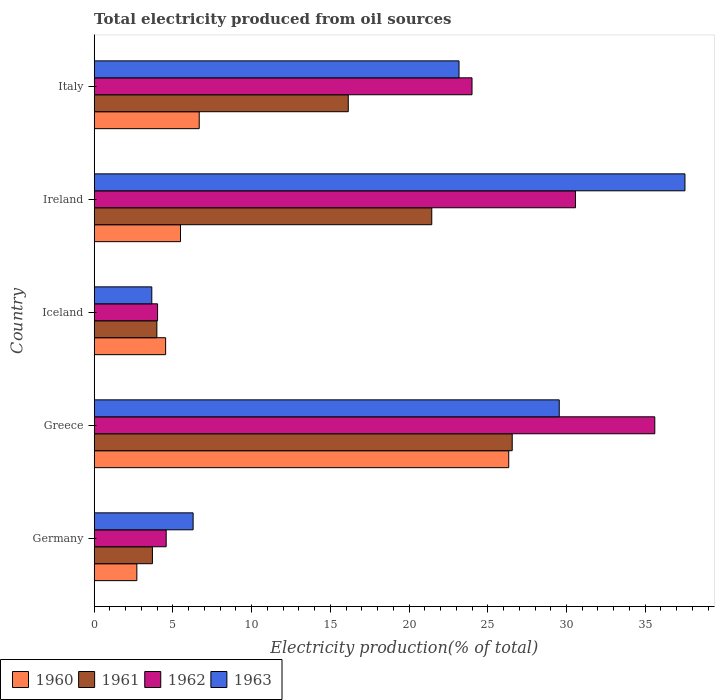How many bars are there on the 3rd tick from the bottom?
Ensure brevity in your answer.  4. What is the total electricity produced in 1962 in Greece?
Your response must be concise. 35.61. Across all countries, what is the maximum total electricity produced in 1963?
Your answer should be very brief. 37.53. Across all countries, what is the minimum total electricity produced in 1960?
Offer a terse response. 2.71. In which country was the total electricity produced in 1961 minimum?
Offer a very short reply. Germany. What is the total total electricity produced in 1962 in the graph?
Ensure brevity in your answer.  98.78. What is the difference between the total electricity produced in 1960 in Greece and that in Ireland?
Offer a very short reply. 20.85. What is the difference between the total electricity produced in 1960 in Iceland and the total electricity produced in 1961 in Germany?
Your response must be concise. 0.84. What is the average total electricity produced in 1963 per country?
Provide a short and direct response. 20.04. What is the difference between the total electricity produced in 1961 and total electricity produced in 1960 in Germany?
Provide a short and direct response. 0.99. In how many countries, is the total electricity produced in 1962 greater than 37 %?
Make the answer very short. 0. What is the ratio of the total electricity produced in 1960 in Greece to that in Ireland?
Offer a very short reply. 4.8. What is the difference between the highest and the second highest total electricity produced in 1963?
Give a very brief answer. 7.99. What is the difference between the highest and the lowest total electricity produced in 1962?
Ensure brevity in your answer.  31.58. Is it the case that in every country, the sum of the total electricity produced in 1961 and total electricity produced in 1963 is greater than the sum of total electricity produced in 1962 and total electricity produced in 1960?
Provide a succinct answer. No. How many bars are there?
Your answer should be very brief. 20. What is the difference between two consecutive major ticks on the X-axis?
Provide a succinct answer. 5. Does the graph contain any zero values?
Ensure brevity in your answer.  No. Does the graph contain grids?
Ensure brevity in your answer.  No. How are the legend labels stacked?
Offer a very short reply. Horizontal. What is the title of the graph?
Provide a succinct answer. Total electricity produced from oil sources. Does "1998" appear as one of the legend labels in the graph?
Offer a terse response. No. What is the label or title of the X-axis?
Ensure brevity in your answer.  Electricity production(% of total). What is the Electricity production(% of total) in 1960 in Germany?
Give a very brief answer. 2.71. What is the Electricity production(% of total) in 1961 in Germany?
Ensure brevity in your answer.  3.7. What is the Electricity production(% of total) of 1962 in Germany?
Make the answer very short. 4.57. What is the Electricity production(% of total) in 1963 in Germany?
Offer a very short reply. 6.28. What is the Electricity production(% of total) of 1960 in Greece?
Your response must be concise. 26.33. What is the Electricity production(% of total) in 1961 in Greece?
Provide a succinct answer. 26.55. What is the Electricity production(% of total) of 1962 in Greece?
Ensure brevity in your answer.  35.61. What is the Electricity production(% of total) of 1963 in Greece?
Offer a terse response. 29.54. What is the Electricity production(% of total) in 1960 in Iceland?
Offer a terse response. 4.54. What is the Electricity production(% of total) in 1961 in Iceland?
Offer a very short reply. 3.98. What is the Electricity production(% of total) of 1962 in Iceland?
Make the answer very short. 4.03. What is the Electricity production(% of total) of 1963 in Iceland?
Provide a short and direct response. 3.66. What is the Electricity production(% of total) in 1960 in Ireland?
Your answer should be very brief. 5.48. What is the Electricity production(% of total) in 1961 in Ireland?
Offer a terse response. 21.44. What is the Electricity production(% of total) of 1962 in Ireland?
Offer a very short reply. 30.57. What is the Electricity production(% of total) in 1963 in Ireland?
Give a very brief answer. 37.53. What is the Electricity production(% of total) of 1960 in Italy?
Ensure brevity in your answer.  6.67. What is the Electricity production(% of total) of 1961 in Italy?
Your response must be concise. 16.14. What is the Electricity production(% of total) in 1962 in Italy?
Provide a short and direct response. 24. What is the Electricity production(% of total) in 1963 in Italy?
Your answer should be compact. 23.17. Across all countries, what is the maximum Electricity production(% of total) in 1960?
Ensure brevity in your answer.  26.33. Across all countries, what is the maximum Electricity production(% of total) of 1961?
Keep it short and to the point. 26.55. Across all countries, what is the maximum Electricity production(% of total) in 1962?
Offer a terse response. 35.61. Across all countries, what is the maximum Electricity production(% of total) of 1963?
Your response must be concise. 37.53. Across all countries, what is the minimum Electricity production(% of total) in 1960?
Provide a short and direct response. 2.71. Across all countries, what is the minimum Electricity production(% of total) in 1961?
Your response must be concise. 3.7. Across all countries, what is the minimum Electricity production(% of total) of 1962?
Ensure brevity in your answer.  4.03. Across all countries, what is the minimum Electricity production(% of total) of 1963?
Make the answer very short. 3.66. What is the total Electricity production(% of total) of 1960 in the graph?
Ensure brevity in your answer.  45.73. What is the total Electricity production(% of total) in 1961 in the graph?
Give a very brief answer. 71.81. What is the total Electricity production(% of total) in 1962 in the graph?
Your response must be concise. 98.78. What is the total Electricity production(% of total) of 1963 in the graph?
Your answer should be compact. 100.18. What is the difference between the Electricity production(% of total) in 1960 in Germany and that in Greece?
Your response must be concise. -23.62. What is the difference between the Electricity production(% of total) of 1961 in Germany and that in Greece?
Your response must be concise. -22.86. What is the difference between the Electricity production(% of total) of 1962 in Germany and that in Greece?
Provide a short and direct response. -31.04. What is the difference between the Electricity production(% of total) of 1963 in Germany and that in Greece?
Keep it short and to the point. -23.26. What is the difference between the Electricity production(% of total) in 1960 in Germany and that in Iceland?
Ensure brevity in your answer.  -1.83. What is the difference between the Electricity production(% of total) of 1961 in Germany and that in Iceland?
Your answer should be very brief. -0.28. What is the difference between the Electricity production(% of total) of 1962 in Germany and that in Iceland?
Your response must be concise. 0.55. What is the difference between the Electricity production(% of total) of 1963 in Germany and that in Iceland?
Provide a short and direct response. 2.63. What is the difference between the Electricity production(% of total) in 1960 in Germany and that in Ireland?
Offer a very short reply. -2.77. What is the difference between the Electricity production(% of total) of 1961 in Germany and that in Ireland?
Your answer should be very brief. -17.75. What is the difference between the Electricity production(% of total) of 1962 in Germany and that in Ireland?
Make the answer very short. -26. What is the difference between the Electricity production(% of total) of 1963 in Germany and that in Ireland?
Provide a succinct answer. -31.24. What is the difference between the Electricity production(% of total) in 1960 in Germany and that in Italy?
Your answer should be very brief. -3.96. What is the difference between the Electricity production(% of total) in 1961 in Germany and that in Italy?
Ensure brevity in your answer.  -12.44. What is the difference between the Electricity production(% of total) in 1962 in Germany and that in Italy?
Keep it short and to the point. -19.43. What is the difference between the Electricity production(% of total) in 1963 in Germany and that in Italy?
Provide a succinct answer. -16.89. What is the difference between the Electricity production(% of total) of 1960 in Greece and that in Iceland?
Provide a short and direct response. 21.79. What is the difference between the Electricity production(% of total) of 1961 in Greece and that in Iceland?
Offer a very short reply. 22.57. What is the difference between the Electricity production(% of total) in 1962 in Greece and that in Iceland?
Provide a succinct answer. 31.58. What is the difference between the Electricity production(% of total) of 1963 in Greece and that in Iceland?
Ensure brevity in your answer.  25.88. What is the difference between the Electricity production(% of total) of 1960 in Greece and that in Ireland?
Your response must be concise. 20.85. What is the difference between the Electricity production(% of total) of 1961 in Greece and that in Ireland?
Offer a very short reply. 5.11. What is the difference between the Electricity production(% of total) of 1962 in Greece and that in Ireland?
Keep it short and to the point. 5.04. What is the difference between the Electricity production(% of total) of 1963 in Greece and that in Ireland?
Offer a terse response. -7.99. What is the difference between the Electricity production(% of total) of 1960 in Greece and that in Italy?
Your answer should be compact. 19.66. What is the difference between the Electricity production(% of total) of 1961 in Greece and that in Italy?
Provide a short and direct response. 10.42. What is the difference between the Electricity production(% of total) in 1962 in Greece and that in Italy?
Keep it short and to the point. 11.61. What is the difference between the Electricity production(% of total) of 1963 in Greece and that in Italy?
Offer a terse response. 6.37. What is the difference between the Electricity production(% of total) of 1960 in Iceland and that in Ireland?
Provide a succinct answer. -0.94. What is the difference between the Electricity production(% of total) of 1961 in Iceland and that in Ireland?
Ensure brevity in your answer.  -17.46. What is the difference between the Electricity production(% of total) of 1962 in Iceland and that in Ireland?
Keep it short and to the point. -26.55. What is the difference between the Electricity production(% of total) in 1963 in Iceland and that in Ireland?
Your response must be concise. -33.87. What is the difference between the Electricity production(% of total) in 1960 in Iceland and that in Italy?
Give a very brief answer. -2.13. What is the difference between the Electricity production(% of total) of 1961 in Iceland and that in Italy?
Your response must be concise. -12.16. What is the difference between the Electricity production(% of total) of 1962 in Iceland and that in Italy?
Make the answer very short. -19.97. What is the difference between the Electricity production(% of total) in 1963 in Iceland and that in Italy?
Give a very brief answer. -19.52. What is the difference between the Electricity production(% of total) in 1960 in Ireland and that in Italy?
Provide a short and direct response. -1.19. What is the difference between the Electricity production(% of total) of 1961 in Ireland and that in Italy?
Your response must be concise. 5.3. What is the difference between the Electricity production(% of total) in 1962 in Ireland and that in Italy?
Give a very brief answer. 6.57. What is the difference between the Electricity production(% of total) in 1963 in Ireland and that in Italy?
Provide a succinct answer. 14.35. What is the difference between the Electricity production(% of total) in 1960 in Germany and the Electricity production(% of total) in 1961 in Greece?
Offer a terse response. -23.85. What is the difference between the Electricity production(% of total) in 1960 in Germany and the Electricity production(% of total) in 1962 in Greece?
Ensure brevity in your answer.  -32.9. What is the difference between the Electricity production(% of total) of 1960 in Germany and the Electricity production(% of total) of 1963 in Greece?
Offer a terse response. -26.83. What is the difference between the Electricity production(% of total) in 1961 in Germany and the Electricity production(% of total) in 1962 in Greece?
Your answer should be compact. -31.91. What is the difference between the Electricity production(% of total) in 1961 in Germany and the Electricity production(% of total) in 1963 in Greece?
Keep it short and to the point. -25.84. What is the difference between the Electricity production(% of total) in 1962 in Germany and the Electricity production(% of total) in 1963 in Greece?
Your answer should be compact. -24.97. What is the difference between the Electricity production(% of total) in 1960 in Germany and the Electricity production(% of total) in 1961 in Iceland?
Offer a very short reply. -1.27. What is the difference between the Electricity production(% of total) in 1960 in Germany and the Electricity production(% of total) in 1962 in Iceland?
Provide a succinct answer. -1.32. What is the difference between the Electricity production(% of total) of 1960 in Germany and the Electricity production(% of total) of 1963 in Iceland?
Give a very brief answer. -0.95. What is the difference between the Electricity production(% of total) of 1961 in Germany and the Electricity production(% of total) of 1962 in Iceland?
Keep it short and to the point. -0.33. What is the difference between the Electricity production(% of total) of 1961 in Germany and the Electricity production(% of total) of 1963 in Iceland?
Offer a terse response. 0.04. What is the difference between the Electricity production(% of total) of 1962 in Germany and the Electricity production(% of total) of 1963 in Iceland?
Keep it short and to the point. 0.91. What is the difference between the Electricity production(% of total) in 1960 in Germany and the Electricity production(% of total) in 1961 in Ireland?
Your response must be concise. -18.73. What is the difference between the Electricity production(% of total) of 1960 in Germany and the Electricity production(% of total) of 1962 in Ireland?
Your answer should be very brief. -27.86. What is the difference between the Electricity production(% of total) in 1960 in Germany and the Electricity production(% of total) in 1963 in Ireland?
Offer a very short reply. -34.82. What is the difference between the Electricity production(% of total) of 1961 in Germany and the Electricity production(% of total) of 1962 in Ireland?
Make the answer very short. -26.87. What is the difference between the Electricity production(% of total) in 1961 in Germany and the Electricity production(% of total) in 1963 in Ireland?
Provide a succinct answer. -33.83. What is the difference between the Electricity production(% of total) of 1962 in Germany and the Electricity production(% of total) of 1963 in Ireland?
Provide a short and direct response. -32.95. What is the difference between the Electricity production(% of total) of 1960 in Germany and the Electricity production(% of total) of 1961 in Italy?
Offer a terse response. -13.43. What is the difference between the Electricity production(% of total) in 1960 in Germany and the Electricity production(% of total) in 1962 in Italy?
Your answer should be very brief. -21.29. What is the difference between the Electricity production(% of total) in 1960 in Germany and the Electricity production(% of total) in 1963 in Italy?
Make the answer very short. -20.47. What is the difference between the Electricity production(% of total) of 1961 in Germany and the Electricity production(% of total) of 1962 in Italy?
Offer a very short reply. -20.3. What is the difference between the Electricity production(% of total) of 1961 in Germany and the Electricity production(% of total) of 1963 in Italy?
Offer a very short reply. -19.48. What is the difference between the Electricity production(% of total) in 1962 in Germany and the Electricity production(% of total) in 1963 in Italy?
Your response must be concise. -18.6. What is the difference between the Electricity production(% of total) of 1960 in Greece and the Electricity production(% of total) of 1961 in Iceland?
Your response must be concise. 22.35. What is the difference between the Electricity production(% of total) in 1960 in Greece and the Electricity production(% of total) in 1962 in Iceland?
Your answer should be very brief. 22.31. What is the difference between the Electricity production(% of total) in 1960 in Greece and the Electricity production(% of total) in 1963 in Iceland?
Give a very brief answer. 22.67. What is the difference between the Electricity production(% of total) in 1961 in Greece and the Electricity production(% of total) in 1962 in Iceland?
Your answer should be compact. 22.53. What is the difference between the Electricity production(% of total) in 1961 in Greece and the Electricity production(% of total) in 1963 in Iceland?
Your answer should be very brief. 22.9. What is the difference between the Electricity production(% of total) of 1962 in Greece and the Electricity production(% of total) of 1963 in Iceland?
Give a very brief answer. 31.95. What is the difference between the Electricity production(% of total) in 1960 in Greece and the Electricity production(% of total) in 1961 in Ireland?
Provide a short and direct response. 4.89. What is the difference between the Electricity production(% of total) in 1960 in Greece and the Electricity production(% of total) in 1962 in Ireland?
Give a very brief answer. -4.24. What is the difference between the Electricity production(% of total) in 1960 in Greece and the Electricity production(% of total) in 1963 in Ireland?
Ensure brevity in your answer.  -11.19. What is the difference between the Electricity production(% of total) in 1961 in Greece and the Electricity production(% of total) in 1962 in Ireland?
Your response must be concise. -4.02. What is the difference between the Electricity production(% of total) of 1961 in Greece and the Electricity production(% of total) of 1963 in Ireland?
Make the answer very short. -10.97. What is the difference between the Electricity production(% of total) of 1962 in Greece and the Electricity production(% of total) of 1963 in Ireland?
Provide a short and direct response. -1.92. What is the difference between the Electricity production(% of total) of 1960 in Greece and the Electricity production(% of total) of 1961 in Italy?
Provide a succinct answer. 10.19. What is the difference between the Electricity production(% of total) of 1960 in Greece and the Electricity production(% of total) of 1962 in Italy?
Ensure brevity in your answer.  2.33. What is the difference between the Electricity production(% of total) of 1960 in Greece and the Electricity production(% of total) of 1963 in Italy?
Your answer should be compact. 3.16. What is the difference between the Electricity production(% of total) in 1961 in Greece and the Electricity production(% of total) in 1962 in Italy?
Offer a very short reply. 2.55. What is the difference between the Electricity production(% of total) of 1961 in Greece and the Electricity production(% of total) of 1963 in Italy?
Give a very brief answer. 3.38. What is the difference between the Electricity production(% of total) of 1962 in Greece and the Electricity production(% of total) of 1963 in Italy?
Ensure brevity in your answer.  12.44. What is the difference between the Electricity production(% of total) in 1960 in Iceland and the Electricity production(% of total) in 1961 in Ireland?
Ensure brevity in your answer.  -16.91. What is the difference between the Electricity production(% of total) in 1960 in Iceland and the Electricity production(% of total) in 1962 in Ireland?
Offer a very short reply. -26.03. What is the difference between the Electricity production(% of total) in 1960 in Iceland and the Electricity production(% of total) in 1963 in Ireland?
Your answer should be very brief. -32.99. What is the difference between the Electricity production(% of total) in 1961 in Iceland and the Electricity production(% of total) in 1962 in Ireland?
Give a very brief answer. -26.59. What is the difference between the Electricity production(% of total) of 1961 in Iceland and the Electricity production(% of total) of 1963 in Ireland?
Offer a terse response. -33.55. What is the difference between the Electricity production(% of total) in 1962 in Iceland and the Electricity production(% of total) in 1963 in Ireland?
Make the answer very short. -33.5. What is the difference between the Electricity production(% of total) of 1960 in Iceland and the Electricity production(% of total) of 1961 in Italy?
Your answer should be very brief. -11.6. What is the difference between the Electricity production(% of total) of 1960 in Iceland and the Electricity production(% of total) of 1962 in Italy?
Provide a short and direct response. -19.46. What is the difference between the Electricity production(% of total) of 1960 in Iceland and the Electricity production(% of total) of 1963 in Italy?
Offer a terse response. -18.64. What is the difference between the Electricity production(% of total) of 1961 in Iceland and the Electricity production(% of total) of 1962 in Italy?
Provide a short and direct response. -20.02. What is the difference between the Electricity production(% of total) of 1961 in Iceland and the Electricity production(% of total) of 1963 in Italy?
Keep it short and to the point. -19.19. What is the difference between the Electricity production(% of total) in 1962 in Iceland and the Electricity production(% of total) in 1963 in Italy?
Make the answer very short. -19.15. What is the difference between the Electricity production(% of total) in 1960 in Ireland and the Electricity production(% of total) in 1961 in Italy?
Ensure brevity in your answer.  -10.66. What is the difference between the Electricity production(% of total) in 1960 in Ireland and the Electricity production(% of total) in 1962 in Italy?
Make the answer very short. -18.52. What is the difference between the Electricity production(% of total) in 1960 in Ireland and the Electricity production(% of total) in 1963 in Italy?
Offer a terse response. -17.69. What is the difference between the Electricity production(% of total) in 1961 in Ireland and the Electricity production(% of total) in 1962 in Italy?
Offer a very short reply. -2.56. What is the difference between the Electricity production(% of total) in 1961 in Ireland and the Electricity production(% of total) in 1963 in Italy?
Provide a short and direct response. -1.73. What is the difference between the Electricity production(% of total) in 1962 in Ireland and the Electricity production(% of total) in 1963 in Italy?
Ensure brevity in your answer.  7.4. What is the average Electricity production(% of total) of 1960 per country?
Keep it short and to the point. 9.15. What is the average Electricity production(% of total) in 1961 per country?
Make the answer very short. 14.36. What is the average Electricity production(% of total) of 1962 per country?
Offer a very short reply. 19.76. What is the average Electricity production(% of total) of 1963 per country?
Provide a short and direct response. 20.04. What is the difference between the Electricity production(% of total) in 1960 and Electricity production(% of total) in 1961 in Germany?
Provide a short and direct response. -0.99. What is the difference between the Electricity production(% of total) of 1960 and Electricity production(% of total) of 1962 in Germany?
Provide a succinct answer. -1.86. What is the difference between the Electricity production(% of total) in 1960 and Electricity production(% of total) in 1963 in Germany?
Offer a very short reply. -3.58. What is the difference between the Electricity production(% of total) of 1961 and Electricity production(% of total) of 1962 in Germany?
Keep it short and to the point. -0.87. What is the difference between the Electricity production(% of total) of 1961 and Electricity production(% of total) of 1963 in Germany?
Your response must be concise. -2.59. What is the difference between the Electricity production(% of total) of 1962 and Electricity production(% of total) of 1963 in Germany?
Your response must be concise. -1.71. What is the difference between the Electricity production(% of total) of 1960 and Electricity production(% of total) of 1961 in Greece?
Your answer should be compact. -0.22. What is the difference between the Electricity production(% of total) of 1960 and Electricity production(% of total) of 1962 in Greece?
Offer a very short reply. -9.28. What is the difference between the Electricity production(% of total) of 1960 and Electricity production(% of total) of 1963 in Greece?
Offer a terse response. -3.21. What is the difference between the Electricity production(% of total) of 1961 and Electricity production(% of total) of 1962 in Greece?
Provide a short and direct response. -9.06. What is the difference between the Electricity production(% of total) in 1961 and Electricity production(% of total) in 1963 in Greece?
Offer a terse response. -2.99. What is the difference between the Electricity production(% of total) in 1962 and Electricity production(% of total) in 1963 in Greece?
Your answer should be compact. 6.07. What is the difference between the Electricity production(% of total) of 1960 and Electricity production(% of total) of 1961 in Iceland?
Give a very brief answer. 0.56. What is the difference between the Electricity production(% of total) of 1960 and Electricity production(% of total) of 1962 in Iceland?
Give a very brief answer. 0.51. What is the difference between the Electricity production(% of total) in 1960 and Electricity production(% of total) in 1963 in Iceland?
Ensure brevity in your answer.  0.88. What is the difference between the Electricity production(% of total) of 1961 and Electricity production(% of total) of 1962 in Iceland?
Provide a succinct answer. -0.05. What is the difference between the Electricity production(% of total) of 1961 and Electricity production(% of total) of 1963 in Iceland?
Your response must be concise. 0.32. What is the difference between the Electricity production(% of total) of 1962 and Electricity production(% of total) of 1963 in Iceland?
Make the answer very short. 0.37. What is the difference between the Electricity production(% of total) of 1960 and Electricity production(% of total) of 1961 in Ireland?
Make the answer very short. -15.96. What is the difference between the Electricity production(% of total) in 1960 and Electricity production(% of total) in 1962 in Ireland?
Provide a short and direct response. -25.09. What is the difference between the Electricity production(% of total) in 1960 and Electricity production(% of total) in 1963 in Ireland?
Your answer should be compact. -32.04. What is the difference between the Electricity production(% of total) of 1961 and Electricity production(% of total) of 1962 in Ireland?
Make the answer very short. -9.13. What is the difference between the Electricity production(% of total) of 1961 and Electricity production(% of total) of 1963 in Ireland?
Provide a succinct answer. -16.08. What is the difference between the Electricity production(% of total) of 1962 and Electricity production(% of total) of 1963 in Ireland?
Your answer should be compact. -6.95. What is the difference between the Electricity production(% of total) of 1960 and Electricity production(% of total) of 1961 in Italy?
Give a very brief answer. -9.47. What is the difference between the Electricity production(% of total) of 1960 and Electricity production(% of total) of 1962 in Italy?
Offer a very short reply. -17.33. What is the difference between the Electricity production(% of total) in 1960 and Electricity production(% of total) in 1963 in Italy?
Provide a succinct answer. -16.5. What is the difference between the Electricity production(% of total) in 1961 and Electricity production(% of total) in 1962 in Italy?
Provide a short and direct response. -7.86. What is the difference between the Electricity production(% of total) in 1961 and Electricity production(% of total) in 1963 in Italy?
Make the answer very short. -7.04. What is the difference between the Electricity production(% of total) in 1962 and Electricity production(% of total) in 1963 in Italy?
Keep it short and to the point. 0.83. What is the ratio of the Electricity production(% of total) of 1960 in Germany to that in Greece?
Your response must be concise. 0.1. What is the ratio of the Electricity production(% of total) of 1961 in Germany to that in Greece?
Provide a succinct answer. 0.14. What is the ratio of the Electricity production(% of total) of 1962 in Germany to that in Greece?
Offer a very short reply. 0.13. What is the ratio of the Electricity production(% of total) in 1963 in Germany to that in Greece?
Offer a terse response. 0.21. What is the ratio of the Electricity production(% of total) in 1960 in Germany to that in Iceland?
Your answer should be very brief. 0.6. What is the ratio of the Electricity production(% of total) of 1961 in Germany to that in Iceland?
Give a very brief answer. 0.93. What is the ratio of the Electricity production(% of total) in 1962 in Germany to that in Iceland?
Ensure brevity in your answer.  1.14. What is the ratio of the Electricity production(% of total) in 1963 in Germany to that in Iceland?
Keep it short and to the point. 1.72. What is the ratio of the Electricity production(% of total) in 1960 in Germany to that in Ireland?
Your response must be concise. 0.49. What is the ratio of the Electricity production(% of total) of 1961 in Germany to that in Ireland?
Give a very brief answer. 0.17. What is the ratio of the Electricity production(% of total) of 1962 in Germany to that in Ireland?
Your answer should be very brief. 0.15. What is the ratio of the Electricity production(% of total) in 1963 in Germany to that in Ireland?
Make the answer very short. 0.17. What is the ratio of the Electricity production(% of total) of 1960 in Germany to that in Italy?
Your answer should be compact. 0.41. What is the ratio of the Electricity production(% of total) in 1961 in Germany to that in Italy?
Your answer should be very brief. 0.23. What is the ratio of the Electricity production(% of total) of 1962 in Germany to that in Italy?
Your response must be concise. 0.19. What is the ratio of the Electricity production(% of total) in 1963 in Germany to that in Italy?
Offer a very short reply. 0.27. What is the ratio of the Electricity production(% of total) in 1960 in Greece to that in Iceland?
Make the answer very short. 5.8. What is the ratio of the Electricity production(% of total) of 1961 in Greece to that in Iceland?
Offer a terse response. 6.67. What is the ratio of the Electricity production(% of total) of 1962 in Greece to that in Iceland?
Your response must be concise. 8.85. What is the ratio of the Electricity production(% of total) in 1963 in Greece to that in Iceland?
Provide a short and direct response. 8.07. What is the ratio of the Electricity production(% of total) of 1960 in Greece to that in Ireland?
Your response must be concise. 4.8. What is the ratio of the Electricity production(% of total) of 1961 in Greece to that in Ireland?
Keep it short and to the point. 1.24. What is the ratio of the Electricity production(% of total) of 1962 in Greece to that in Ireland?
Make the answer very short. 1.16. What is the ratio of the Electricity production(% of total) of 1963 in Greece to that in Ireland?
Provide a short and direct response. 0.79. What is the ratio of the Electricity production(% of total) of 1960 in Greece to that in Italy?
Your response must be concise. 3.95. What is the ratio of the Electricity production(% of total) in 1961 in Greece to that in Italy?
Your answer should be compact. 1.65. What is the ratio of the Electricity production(% of total) of 1962 in Greece to that in Italy?
Keep it short and to the point. 1.48. What is the ratio of the Electricity production(% of total) of 1963 in Greece to that in Italy?
Ensure brevity in your answer.  1.27. What is the ratio of the Electricity production(% of total) of 1960 in Iceland to that in Ireland?
Your answer should be very brief. 0.83. What is the ratio of the Electricity production(% of total) in 1961 in Iceland to that in Ireland?
Your response must be concise. 0.19. What is the ratio of the Electricity production(% of total) in 1962 in Iceland to that in Ireland?
Offer a very short reply. 0.13. What is the ratio of the Electricity production(% of total) in 1963 in Iceland to that in Ireland?
Offer a very short reply. 0.1. What is the ratio of the Electricity production(% of total) in 1960 in Iceland to that in Italy?
Offer a very short reply. 0.68. What is the ratio of the Electricity production(% of total) in 1961 in Iceland to that in Italy?
Provide a succinct answer. 0.25. What is the ratio of the Electricity production(% of total) in 1962 in Iceland to that in Italy?
Provide a succinct answer. 0.17. What is the ratio of the Electricity production(% of total) of 1963 in Iceland to that in Italy?
Your answer should be compact. 0.16. What is the ratio of the Electricity production(% of total) of 1960 in Ireland to that in Italy?
Offer a terse response. 0.82. What is the ratio of the Electricity production(% of total) of 1961 in Ireland to that in Italy?
Your answer should be compact. 1.33. What is the ratio of the Electricity production(% of total) of 1962 in Ireland to that in Italy?
Offer a very short reply. 1.27. What is the ratio of the Electricity production(% of total) of 1963 in Ireland to that in Italy?
Provide a short and direct response. 1.62. What is the difference between the highest and the second highest Electricity production(% of total) in 1960?
Ensure brevity in your answer.  19.66. What is the difference between the highest and the second highest Electricity production(% of total) in 1961?
Your answer should be compact. 5.11. What is the difference between the highest and the second highest Electricity production(% of total) in 1962?
Provide a short and direct response. 5.04. What is the difference between the highest and the second highest Electricity production(% of total) in 1963?
Keep it short and to the point. 7.99. What is the difference between the highest and the lowest Electricity production(% of total) of 1960?
Ensure brevity in your answer.  23.62. What is the difference between the highest and the lowest Electricity production(% of total) in 1961?
Give a very brief answer. 22.86. What is the difference between the highest and the lowest Electricity production(% of total) in 1962?
Give a very brief answer. 31.58. What is the difference between the highest and the lowest Electricity production(% of total) of 1963?
Keep it short and to the point. 33.87. 